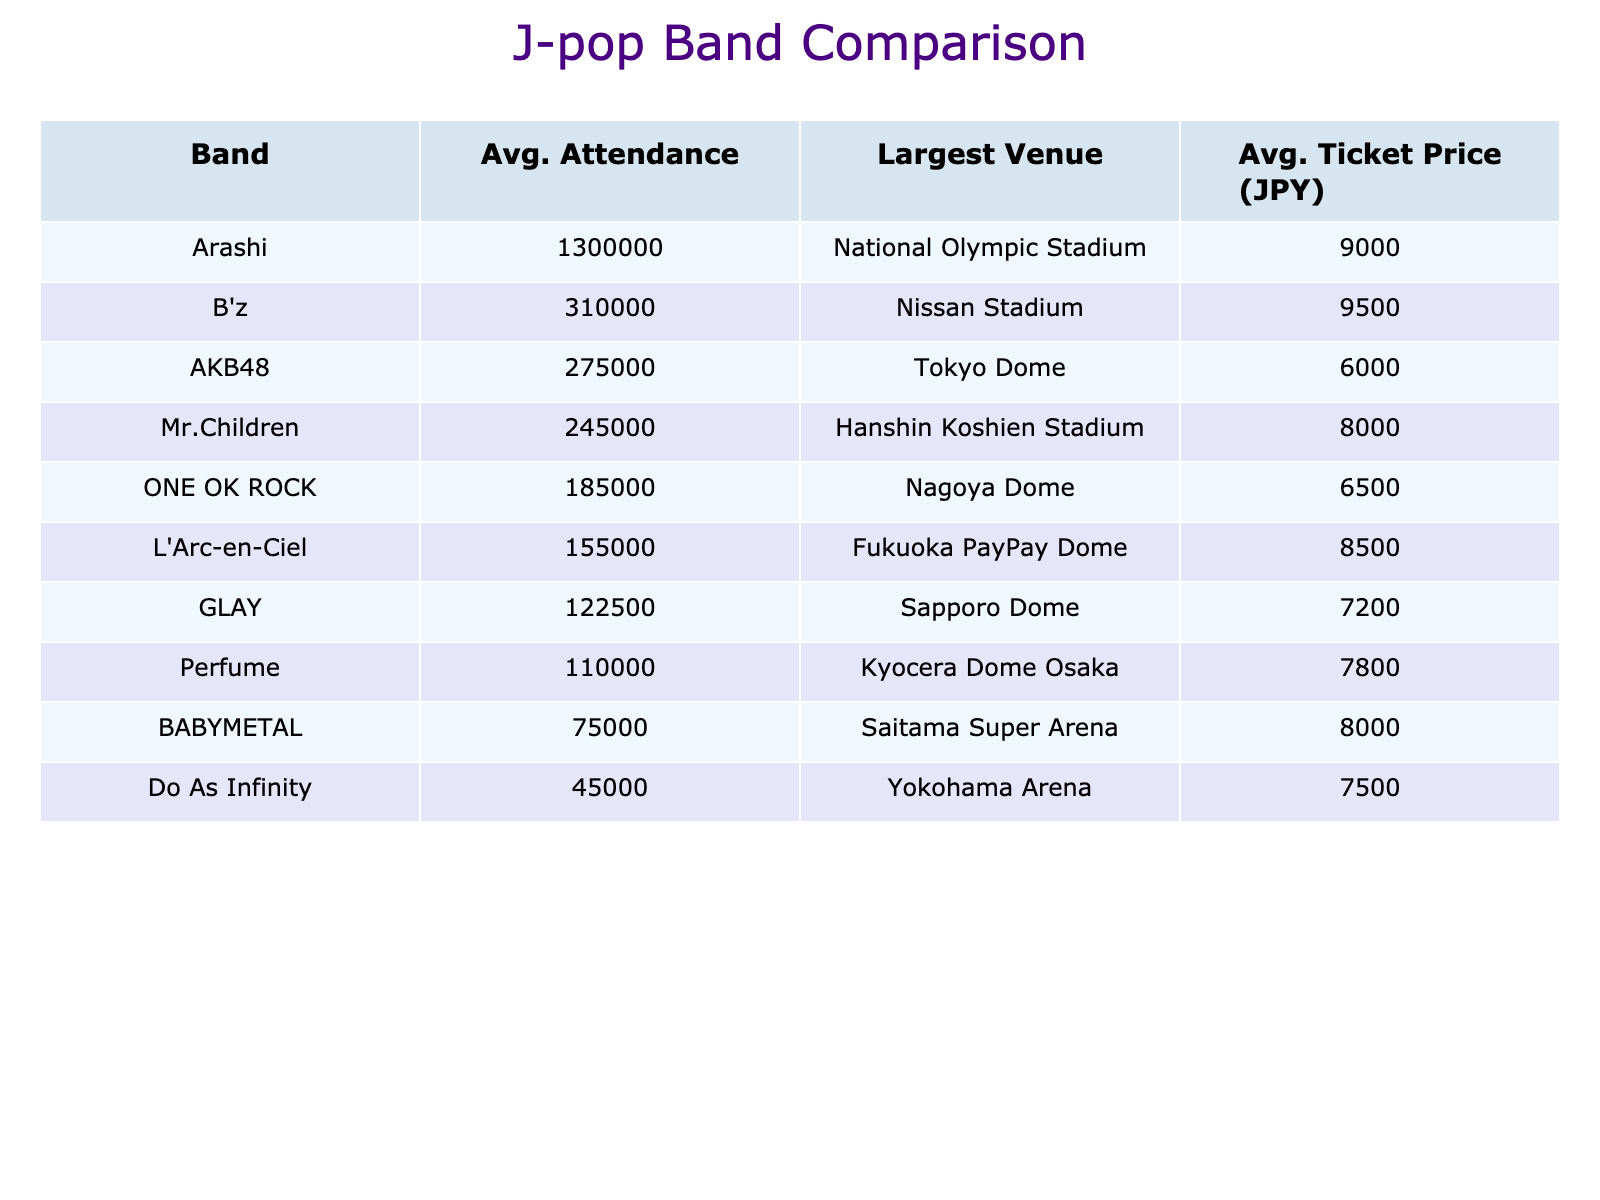What is the largest venue for Do As Infinity? According to the table, the largest venue listed for Do As Infinity is the Yokohama Arena.
Answer: Yokohama Arena What is the average attendance for B'z? To calculate the average attendance for B'z, we sum the attendance figures from 2019 (500000), 2020 (120000), 2021 (180000), and 2022 (550000). The total is 500000 + 120000 + 180000 + 550000 = 1350000. Then we divide by the number of years (4) to get the average: 1350000 / 4 = 337500.
Answer: 337500 Which band had the highest attendance in 2022? By comparing the attendance figures for 2022, we see that Arashi had the highest attendance with "Hiatus", meaning they did not have an event in 2022. The next highest figure is Do As Infinity with 80000 attendees. Hence, nobody beat Arashi, but among performing bands, Do As Infinity is the highest.
Answer: Do As Infinity Is the average ticket price for AKB48 lower than that of ONE OK ROCK? Looking at the table, the average ticket price for AKB48 is 6000 JPY, while that for ONE OK ROCK is 6500 JPY. Since 6000 is less than 6500, we can confirm that AKB48's ticket price is indeed lower.
Answer: Yes What is the difference in average attendance between Perfume and GLAY? First, we need to compute the average attendance for Perfume: (180000 + 40000 + 60000 + 200000) / 4 = 81750. Next, for GLAY: (200000 + 45000 + 70000 + 220000) / 4 = 103750. Now we find the difference: 103750 - 81750 = 22000.
Answer: 22000 Which band had the lowest attendance in 2021? Looking through the attendance figures for 2021, Do As Infinity had an attendance of 25000, while the other bands had higher figures. Therefore, Do As Infinity had the lowest attendance in that year.
Answer: Do As Infinity Did Mr.Children have a consistently increasing attendance from 2019 to 2022? Analyzing the attendance figures for Mr.Children shows: 2019 (400000), 2020 (90000), 2021 (140000), and 2022 (450000). The attendance decreased from 2019 to 2020, went up to 140000 in 2021, then increased again to 450000 in 2022. Thus, attendance was not consistently increasing throughout this period.
Answer: No What is the average attendance for all bands in 2020? We calculate the average attendance for all bands in 2020 by summing the specific attendances for that year: (15000 + 100000 + 500000 + 30000 + 40000 + 70000 + 60000 + 120000 + 45000 + 90000) = 880000. Then divide by the number of bands (10): 880000 / 10 = 88000.
Answer: 88000 Which band has the highest average ticket price and what is it? Scanning through the ticket prices listed, B'z has the highest average ticket price at 9500 JPY, compared to others.
Answer: B'z, 9500 JPY 